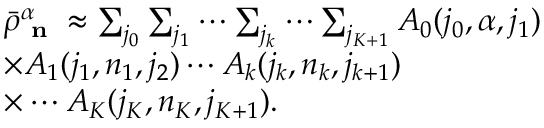Convert formula to latex. <formula><loc_0><loc_0><loc_500><loc_500>\begin{array} { r l } & { \bar { \rho } _ { n } ^ { \alpha } \approx \sum _ { j _ { 0 } } \sum _ { j _ { 1 } } \cdots \sum _ { j _ { k } } \cdots \sum _ { j _ { K + 1 } } A _ { 0 } ( j _ { 0 } , \alpha , j _ { 1 } ) } \\ & { \times A _ { 1 } ( j _ { 1 } , n _ { 1 } , j _ { 2 } ) \cdots A _ { k } ( j _ { k } , n _ { k } , j _ { k + 1 } ) } \\ & { \times \cdots A _ { K } ( j _ { K } , n _ { K } , j _ { K + 1 } ) . } \end{array}</formula> 